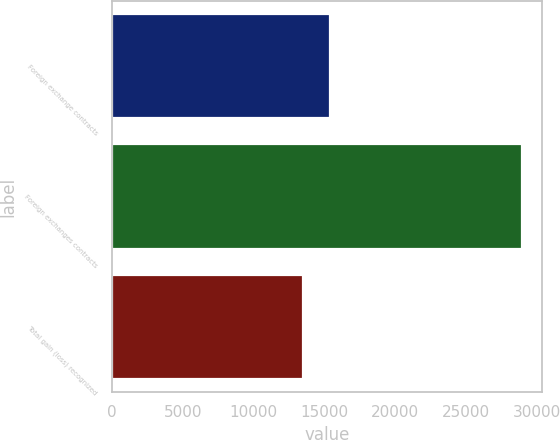Convert chart to OTSL. <chart><loc_0><loc_0><loc_500><loc_500><bar_chart><fcel>Foreign exchange contracts<fcel>Foreign exchanges contracts<fcel>Total gain (loss) recognized<nl><fcel>15430<fcel>28933<fcel>13503<nl></chart> 